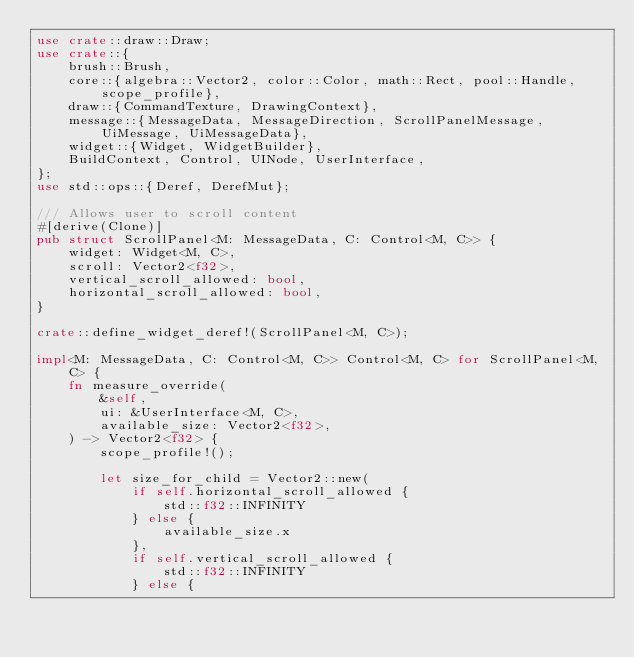<code> <loc_0><loc_0><loc_500><loc_500><_Rust_>use crate::draw::Draw;
use crate::{
    brush::Brush,
    core::{algebra::Vector2, color::Color, math::Rect, pool::Handle, scope_profile},
    draw::{CommandTexture, DrawingContext},
    message::{MessageData, MessageDirection, ScrollPanelMessage, UiMessage, UiMessageData},
    widget::{Widget, WidgetBuilder},
    BuildContext, Control, UINode, UserInterface,
};
use std::ops::{Deref, DerefMut};

/// Allows user to scroll content
#[derive(Clone)]
pub struct ScrollPanel<M: MessageData, C: Control<M, C>> {
    widget: Widget<M, C>,
    scroll: Vector2<f32>,
    vertical_scroll_allowed: bool,
    horizontal_scroll_allowed: bool,
}

crate::define_widget_deref!(ScrollPanel<M, C>);

impl<M: MessageData, C: Control<M, C>> Control<M, C> for ScrollPanel<M, C> {
    fn measure_override(
        &self,
        ui: &UserInterface<M, C>,
        available_size: Vector2<f32>,
    ) -> Vector2<f32> {
        scope_profile!();

        let size_for_child = Vector2::new(
            if self.horizontal_scroll_allowed {
                std::f32::INFINITY
            } else {
                available_size.x
            },
            if self.vertical_scroll_allowed {
                std::f32::INFINITY
            } else {</code> 